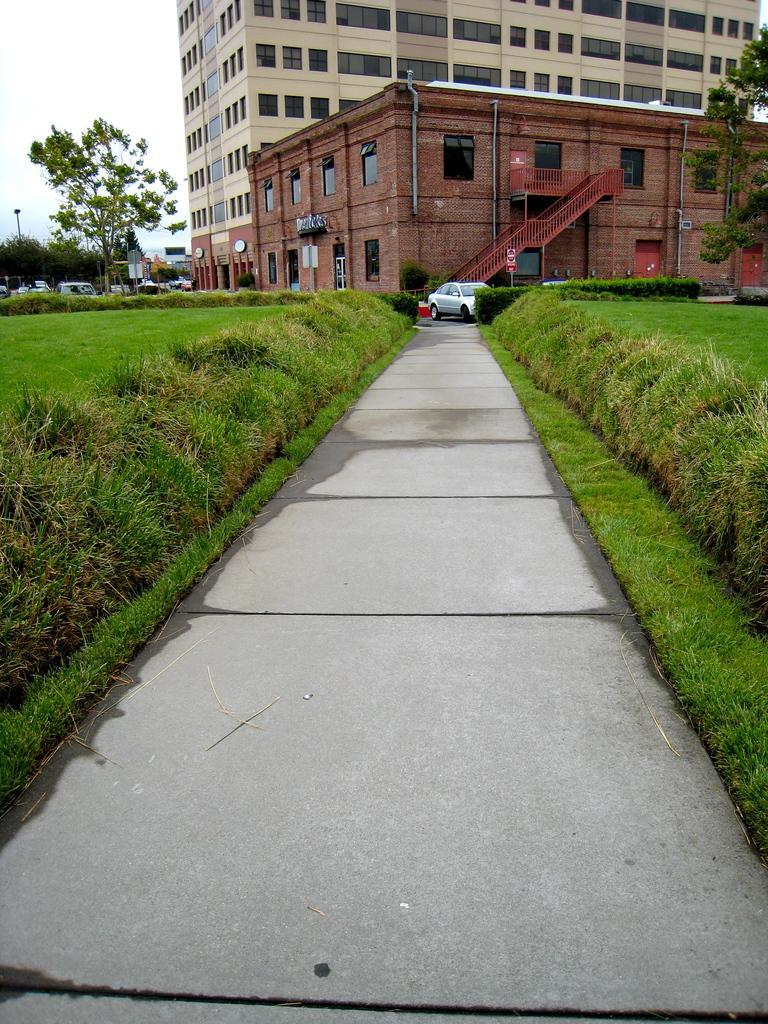Please provide a concise description of this image. In this image we can see buildings with windows, stairs, vehicles, trees, grass and sky. 